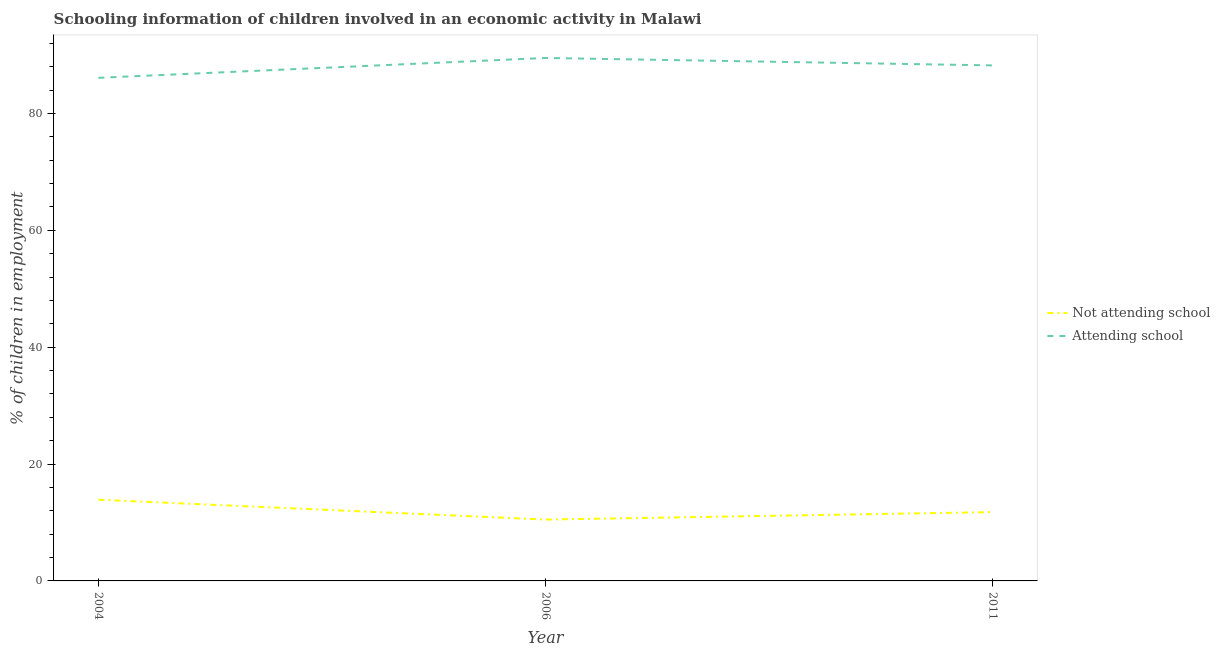How many different coloured lines are there?
Provide a succinct answer. 2. What is the percentage of employed children who are not attending school in 2011?
Offer a terse response. 11.78. Across all years, what is the maximum percentage of employed children who are attending school?
Give a very brief answer. 89.5. Across all years, what is the minimum percentage of employed children who are attending school?
Give a very brief answer. 86.1. What is the total percentage of employed children who are attending school in the graph?
Your answer should be compact. 263.82. What is the difference between the percentage of employed children who are not attending school in 2004 and that in 2006?
Your response must be concise. 3.4. What is the difference between the percentage of employed children who are attending school in 2011 and the percentage of employed children who are not attending school in 2006?
Ensure brevity in your answer.  77.72. What is the average percentage of employed children who are not attending school per year?
Ensure brevity in your answer.  12.06. In the year 2004, what is the difference between the percentage of employed children who are not attending school and percentage of employed children who are attending school?
Offer a very short reply. -72.2. What is the ratio of the percentage of employed children who are attending school in 2006 to that in 2011?
Make the answer very short. 1.01. Is the difference between the percentage of employed children who are attending school in 2006 and 2011 greater than the difference between the percentage of employed children who are not attending school in 2006 and 2011?
Offer a terse response. Yes. What is the difference between the highest and the second highest percentage of employed children who are attending school?
Provide a short and direct response. 1.28. What is the difference between the highest and the lowest percentage of employed children who are not attending school?
Your answer should be compact. 3.4. In how many years, is the percentage of employed children who are attending school greater than the average percentage of employed children who are attending school taken over all years?
Offer a very short reply. 2. Is the percentage of employed children who are attending school strictly greater than the percentage of employed children who are not attending school over the years?
Keep it short and to the point. Yes. Is the percentage of employed children who are not attending school strictly less than the percentage of employed children who are attending school over the years?
Your answer should be very brief. Yes. How many lines are there?
Keep it short and to the point. 2. How many years are there in the graph?
Ensure brevity in your answer.  3. Are the values on the major ticks of Y-axis written in scientific E-notation?
Offer a terse response. No. Does the graph contain any zero values?
Your response must be concise. No. What is the title of the graph?
Offer a very short reply. Schooling information of children involved in an economic activity in Malawi. What is the label or title of the X-axis?
Your answer should be compact. Year. What is the label or title of the Y-axis?
Provide a short and direct response. % of children in employment. What is the % of children in employment of Attending school in 2004?
Keep it short and to the point. 86.1. What is the % of children in employment of Attending school in 2006?
Offer a very short reply. 89.5. What is the % of children in employment of Not attending school in 2011?
Your answer should be compact. 11.78. What is the % of children in employment of Attending school in 2011?
Your response must be concise. 88.22. Across all years, what is the maximum % of children in employment of Not attending school?
Keep it short and to the point. 13.9. Across all years, what is the maximum % of children in employment of Attending school?
Your answer should be very brief. 89.5. Across all years, what is the minimum % of children in employment of Not attending school?
Ensure brevity in your answer.  10.5. Across all years, what is the minimum % of children in employment in Attending school?
Offer a very short reply. 86.1. What is the total % of children in employment of Not attending school in the graph?
Ensure brevity in your answer.  36.18. What is the total % of children in employment of Attending school in the graph?
Give a very brief answer. 263.82. What is the difference between the % of children in employment of Not attending school in 2004 and that in 2006?
Provide a succinct answer. 3.4. What is the difference between the % of children in employment in Attending school in 2004 and that in 2006?
Give a very brief answer. -3.4. What is the difference between the % of children in employment of Not attending school in 2004 and that in 2011?
Provide a short and direct response. 2.12. What is the difference between the % of children in employment in Attending school in 2004 and that in 2011?
Keep it short and to the point. -2.12. What is the difference between the % of children in employment in Not attending school in 2006 and that in 2011?
Your answer should be compact. -1.28. What is the difference between the % of children in employment in Attending school in 2006 and that in 2011?
Offer a terse response. 1.28. What is the difference between the % of children in employment of Not attending school in 2004 and the % of children in employment of Attending school in 2006?
Keep it short and to the point. -75.6. What is the difference between the % of children in employment of Not attending school in 2004 and the % of children in employment of Attending school in 2011?
Your response must be concise. -74.32. What is the difference between the % of children in employment in Not attending school in 2006 and the % of children in employment in Attending school in 2011?
Provide a succinct answer. -77.72. What is the average % of children in employment of Not attending school per year?
Provide a short and direct response. 12.06. What is the average % of children in employment in Attending school per year?
Provide a succinct answer. 87.94. In the year 2004, what is the difference between the % of children in employment of Not attending school and % of children in employment of Attending school?
Keep it short and to the point. -72.2. In the year 2006, what is the difference between the % of children in employment in Not attending school and % of children in employment in Attending school?
Provide a succinct answer. -79. In the year 2011, what is the difference between the % of children in employment in Not attending school and % of children in employment in Attending school?
Offer a very short reply. -76.45. What is the ratio of the % of children in employment in Not attending school in 2004 to that in 2006?
Provide a short and direct response. 1.32. What is the ratio of the % of children in employment in Not attending school in 2004 to that in 2011?
Provide a succinct answer. 1.18. What is the ratio of the % of children in employment of Attending school in 2004 to that in 2011?
Make the answer very short. 0.98. What is the ratio of the % of children in employment in Not attending school in 2006 to that in 2011?
Make the answer very short. 0.89. What is the ratio of the % of children in employment of Attending school in 2006 to that in 2011?
Keep it short and to the point. 1.01. What is the difference between the highest and the second highest % of children in employment of Not attending school?
Offer a very short reply. 2.12. What is the difference between the highest and the second highest % of children in employment of Attending school?
Your response must be concise. 1.28. What is the difference between the highest and the lowest % of children in employment in Not attending school?
Provide a succinct answer. 3.4. 